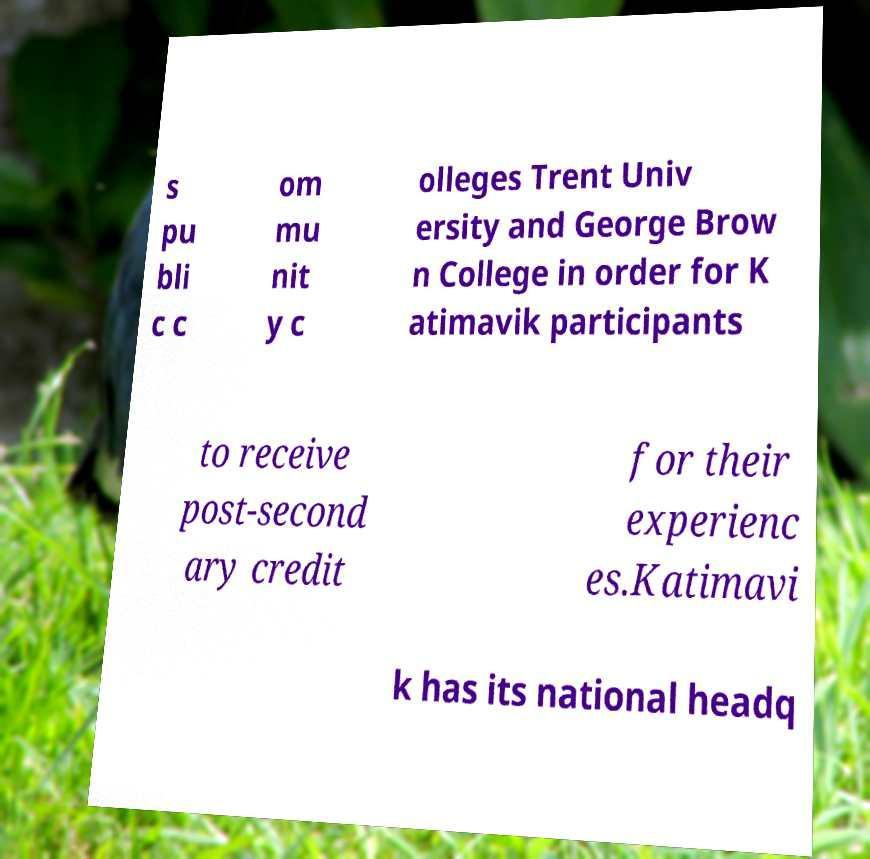What messages or text are displayed in this image? I need them in a readable, typed format. s pu bli c c om mu nit y c olleges Trent Univ ersity and George Brow n College in order for K atimavik participants to receive post-second ary credit for their experienc es.Katimavi k has its national headq 